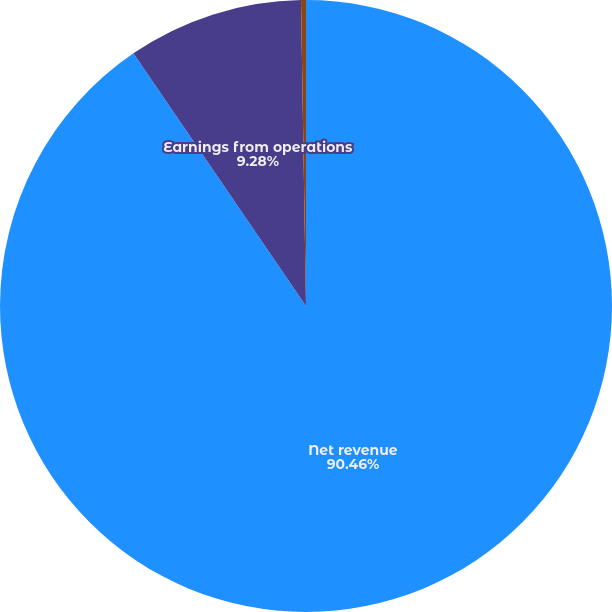<chart> <loc_0><loc_0><loc_500><loc_500><pie_chart><fcel>Net revenue<fcel>Earnings from operations<fcel>Earnings from operations as a<nl><fcel>90.47%<fcel>9.28%<fcel>0.26%<nl></chart> 